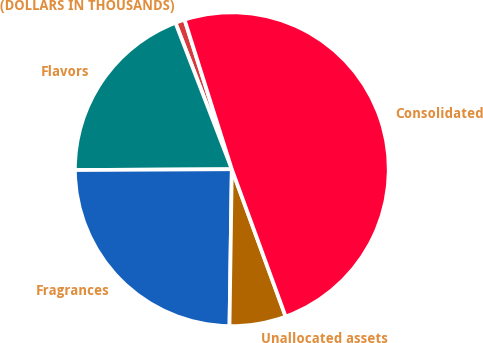Convert chart. <chart><loc_0><loc_0><loc_500><loc_500><pie_chart><fcel>(DOLLARS IN THOUSANDS)<fcel>Flavors<fcel>Fragrances<fcel>Unallocated assets<fcel>Consolidated<nl><fcel>0.98%<fcel>19.23%<fcel>24.68%<fcel>5.81%<fcel>49.29%<nl></chart> 